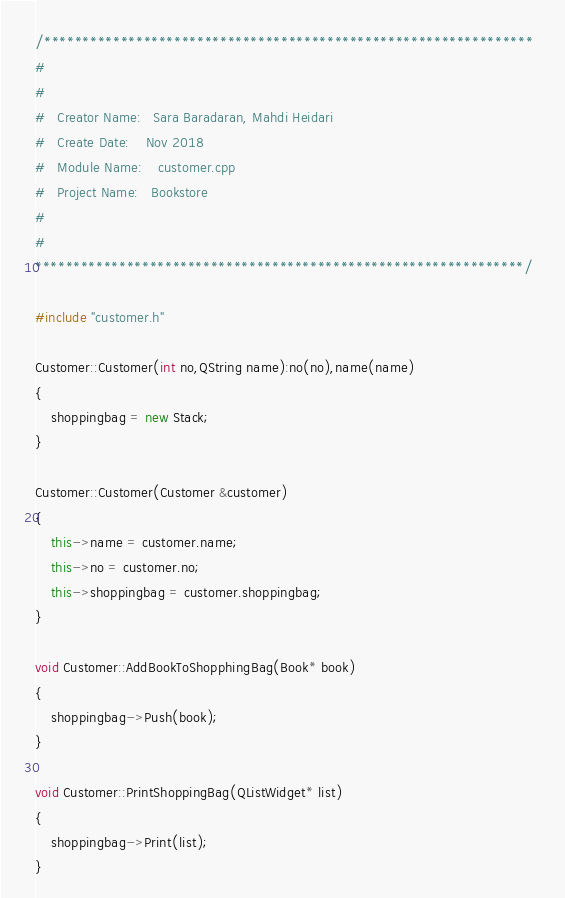Convert code to text. <code><loc_0><loc_0><loc_500><loc_500><_C++_>/****************************************************************  
#								
# 								
# 	Creator Name:   Sara Baradaran, Mahdi Heidari		
# 	Create Date:    Nov 2018 				
# 	Module Name:    customer.cpp
# 	Project Name:   Bookstore	
#								
#								
****************************************************************/

#include "customer.h"

Customer::Customer(int no,QString name):no(no),name(name)
{
    shoppingbag = new Stack;
}

Customer::Customer(Customer &customer)
{
    this->name = customer.name;
    this->no = customer.no;
    this->shoppingbag = customer.shoppingbag;
}

void Customer::AddBookToShopphingBag(Book* book)
{
    shoppingbag->Push(book);
}

void Customer::PrintShoppingBag(QListWidget* list)
{
    shoppingbag->Print(list);
}
</code> 